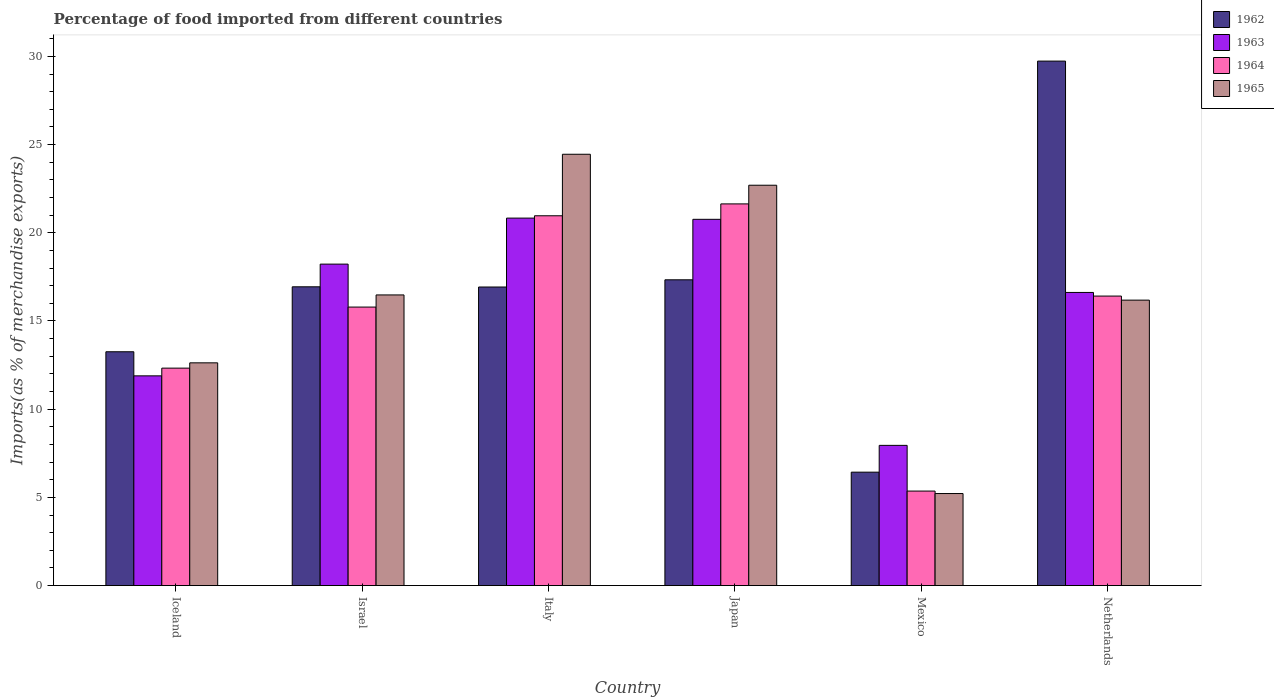How many groups of bars are there?
Provide a succinct answer. 6. Are the number of bars per tick equal to the number of legend labels?
Keep it short and to the point. Yes. Are the number of bars on each tick of the X-axis equal?
Provide a succinct answer. Yes. How many bars are there on the 4th tick from the left?
Make the answer very short. 4. How many bars are there on the 4th tick from the right?
Ensure brevity in your answer.  4. What is the percentage of imports to different countries in 1962 in Israel?
Make the answer very short. 16.94. Across all countries, what is the maximum percentage of imports to different countries in 1965?
Give a very brief answer. 24.45. Across all countries, what is the minimum percentage of imports to different countries in 1964?
Your response must be concise. 5.36. What is the total percentage of imports to different countries in 1962 in the graph?
Offer a very short reply. 100.62. What is the difference between the percentage of imports to different countries in 1964 in Italy and that in Netherlands?
Offer a terse response. 4.55. What is the difference between the percentage of imports to different countries in 1963 in Iceland and the percentage of imports to different countries in 1964 in Netherlands?
Make the answer very short. -4.52. What is the average percentage of imports to different countries in 1964 per country?
Your answer should be very brief. 15.42. What is the difference between the percentage of imports to different countries of/in 1962 and percentage of imports to different countries of/in 1963 in Israel?
Give a very brief answer. -1.29. In how many countries, is the percentage of imports to different countries in 1964 greater than 21 %?
Make the answer very short. 1. What is the ratio of the percentage of imports to different countries in 1963 in Israel to that in Mexico?
Provide a succinct answer. 2.29. Is the difference between the percentage of imports to different countries in 1962 in Iceland and Mexico greater than the difference between the percentage of imports to different countries in 1963 in Iceland and Mexico?
Keep it short and to the point. Yes. What is the difference between the highest and the second highest percentage of imports to different countries in 1962?
Your answer should be very brief. -0.4. What is the difference between the highest and the lowest percentage of imports to different countries in 1963?
Give a very brief answer. 12.88. In how many countries, is the percentage of imports to different countries in 1962 greater than the average percentage of imports to different countries in 1962 taken over all countries?
Offer a terse response. 4. Is it the case that in every country, the sum of the percentage of imports to different countries in 1963 and percentage of imports to different countries in 1962 is greater than the sum of percentage of imports to different countries in 1965 and percentage of imports to different countries in 1964?
Your answer should be compact. No. What does the 4th bar from the left in Netherlands represents?
Your response must be concise. 1965. How many bars are there?
Your answer should be compact. 24. Are all the bars in the graph horizontal?
Your response must be concise. No. Does the graph contain any zero values?
Your response must be concise. No. Where does the legend appear in the graph?
Your answer should be very brief. Top right. How are the legend labels stacked?
Ensure brevity in your answer.  Vertical. What is the title of the graph?
Keep it short and to the point. Percentage of food imported from different countries. What is the label or title of the Y-axis?
Provide a short and direct response. Imports(as % of merchandise exports). What is the Imports(as % of merchandise exports) of 1962 in Iceland?
Offer a terse response. 13.26. What is the Imports(as % of merchandise exports) in 1963 in Iceland?
Keep it short and to the point. 11.89. What is the Imports(as % of merchandise exports) in 1964 in Iceland?
Your answer should be compact. 12.33. What is the Imports(as % of merchandise exports) in 1965 in Iceland?
Your answer should be very brief. 12.63. What is the Imports(as % of merchandise exports) of 1962 in Israel?
Ensure brevity in your answer.  16.94. What is the Imports(as % of merchandise exports) of 1963 in Israel?
Your answer should be compact. 18.22. What is the Imports(as % of merchandise exports) of 1964 in Israel?
Offer a terse response. 15.79. What is the Imports(as % of merchandise exports) in 1965 in Israel?
Provide a short and direct response. 16.48. What is the Imports(as % of merchandise exports) of 1962 in Italy?
Give a very brief answer. 16.93. What is the Imports(as % of merchandise exports) in 1963 in Italy?
Give a very brief answer. 20.83. What is the Imports(as % of merchandise exports) in 1964 in Italy?
Provide a short and direct response. 20.97. What is the Imports(as % of merchandise exports) of 1965 in Italy?
Provide a short and direct response. 24.45. What is the Imports(as % of merchandise exports) in 1962 in Japan?
Ensure brevity in your answer.  17.34. What is the Imports(as % of merchandise exports) in 1963 in Japan?
Your answer should be compact. 20.76. What is the Imports(as % of merchandise exports) in 1964 in Japan?
Your answer should be very brief. 21.64. What is the Imports(as % of merchandise exports) in 1965 in Japan?
Keep it short and to the point. 22.7. What is the Imports(as % of merchandise exports) of 1962 in Mexico?
Provide a succinct answer. 6.43. What is the Imports(as % of merchandise exports) of 1963 in Mexico?
Give a very brief answer. 7.95. What is the Imports(as % of merchandise exports) in 1964 in Mexico?
Keep it short and to the point. 5.36. What is the Imports(as % of merchandise exports) of 1965 in Mexico?
Your response must be concise. 5.22. What is the Imports(as % of merchandise exports) in 1962 in Netherlands?
Provide a short and direct response. 29.73. What is the Imports(as % of merchandise exports) of 1963 in Netherlands?
Provide a short and direct response. 16.62. What is the Imports(as % of merchandise exports) of 1964 in Netherlands?
Provide a short and direct response. 16.41. What is the Imports(as % of merchandise exports) of 1965 in Netherlands?
Offer a terse response. 16.18. Across all countries, what is the maximum Imports(as % of merchandise exports) of 1962?
Your answer should be compact. 29.73. Across all countries, what is the maximum Imports(as % of merchandise exports) of 1963?
Offer a terse response. 20.83. Across all countries, what is the maximum Imports(as % of merchandise exports) of 1964?
Offer a very short reply. 21.64. Across all countries, what is the maximum Imports(as % of merchandise exports) of 1965?
Your response must be concise. 24.45. Across all countries, what is the minimum Imports(as % of merchandise exports) of 1962?
Your answer should be compact. 6.43. Across all countries, what is the minimum Imports(as % of merchandise exports) in 1963?
Provide a succinct answer. 7.95. Across all countries, what is the minimum Imports(as % of merchandise exports) in 1964?
Give a very brief answer. 5.36. Across all countries, what is the minimum Imports(as % of merchandise exports) in 1965?
Make the answer very short. 5.22. What is the total Imports(as % of merchandise exports) in 1962 in the graph?
Your response must be concise. 100.62. What is the total Imports(as % of merchandise exports) of 1963 in the graph?
Your answer should be compact. 96.28. What is the total Imports(as % of merchandise exports) in 1964 in the graph?
Your response must be concise. 92.49. What is the total Imports(as % of merchandise exports) of 1965 in the graph?
Provide a succinct answer. 97.65. What is the difference between the Imports(as % of merchandise exports) in 1962 in Iceland and that in Israel?
Provide a short and direct response. -3.68. What is the difference between the Imports(as % of merchandise exports) of 1963 in Iceland and that in Israel?
Keep it short and to the point. -6.33. What is the difference between the Imports(as % of merchandise exports) in 1964 in Iceland and that in Israel?
Ensure brevity in your answer.  -3.46. What is the difference between the Imports(as % of merchandise exports) of 1965 in Iceland and that in Israel?
Ensure brevity in your answer.  -3.85. What is the difference between the Imports(as % of merchandise exports) of 1962 in Iceland and that in Italy?
Provide a short and direct response. -3.67. What is the difference between the Imports(as % of merchandise exports) of 1963 in Iceland and that in Italy?
Offer a terse response. -8.94. What is the difference between the Imports(as % of merchandise exports) of 1964 in Iceland and that in Italy?
Make the answer very short. -8.64. What is the difference between the Imports(as % of merchandise exports) of 1965 in Iceland and that in Italy?
Keep it short and to the point. -11.82. What is the difference between the Imports(as % of merchandise exports) of 1962 in Iceland and that in Japan?
Ensure brevity in your answer.  -4.08. What is the difference between the Imports(as % of merchandise exports) of 1963 in Iceland and that in Japan?
Your answer should be compact. -8.87. What is the difference between the Imports(as % of merchandise exports) in 1964 in Iceland and that in Japan?
Offer a very short reply. -9.31. What is the difference between the Imports(as % of merchandise exports) of 1965 in Iceland and that in Japan?
Offer a very short reply. -10.07. What is the difference between the Imports(as % of merchandise exports) in 1962 in Iceland and that in Mexico?
Provide a short and direct response. 6.83. What is the difference between the Imports(as % of merchandise exports) of 1963 in Iceland and that in Mexico?
Offer a terse response. 3.94. What is the difference between the Imports(as % of merchandise exports) in 1964 in Iceland and that in Mexico?
Your response must be concise. 6.97. What is the difference between the Imports(as % of merchandise exports) of 1965 in Iceland and that in Mexico?
Offer a very short reply. 7.41. What is the difference between the Imports(as % of merchandise exports) in 1962 in Iceland and that in Netherlands?
Offer a very short reply. -16.48. What is the difference between the Imports(as % of merchandise exports) of 1963 in Iceland and that in Netherlands?
Give a very brief answer. -4.73. What is the difference between the Imports(as % of merchandise exports) in 1964 in Iceland and that in Netherlands?
Make the answer very short. -4.08. What is the difference between the Imports(as % of merchandise exports) in 1965 in Iceland and that in Netherlands?
Make the answer very short. -3.56. What is the difference between the Imports(as % of merchandise exports) in 1962 in Israel and that in Italy?
Make the answer very short. 0.01. What is the difference between the Imports(as % of merchandise exports) in 1963 in Israel and that in Italy?
Keep it short and to the point. -2.61. What is the difference between the Imports(as % of merchandise exports) in 1964 in Israel and that in Italy?
Give a very brief answer. -5.18. What is the difference between the Imports(as % of merchandise exports) in 1965 in Israel and that in Italy?
Provide a short and direct response. -7.97. What is the difference between the Imports(as % of merchandise exports) in 1962 in Israel and that in Japan?
Offer a terse response. -0.4. What is the difference between the Imports(as % of merchandise exports) of 1963 in Israel and that in Japan?
Offer a very short reply. -2.54. What is the difference between the Imports(as % of merchandise exports) in 1964 in Israel and that in Japan?
Offer a terse response. -5.85. What is the difference between the Imports(as % of merchandise exports) in 1965 in Israel and that in Japan?
Ensure brevity in your answer.  -6.22. What is the difference between the Imports(as % of merchandise exports) in 1962 in Israel and that in Mexico?
Provide a short and direct response. 10.51. What is the difference between the Imports(as % of merchandise exports) of 1963 in Israel and that in Mexico?
Make the answer very short. 10.28. What is the difference between the Imports(as % of merchandise exports) in 1964 in Israel and that in Mexico?
Your answer should be very brief. 10.43. What is the difference between the Imports(as % of merchandise exports) in 1965 in Israel and that in Mexico?
Your answer should be very brief. 11.26. What is the difference between the Imports(as % of merchandise exports) in 1962 in Israel and that in Netherlands?
Ensure brevity in your answer.  -12.8. What is the difference between the Imports(as % of merchandise exports) in 1963 in Israel and that in Netherlands?
Keep it short and to the point. 1.61. What is the difference between the Imports(as % of merchandise exports) in 1964 in Israel and that in Netherlands?
Give a very brief answer. -0.62. What is the difference between the Imports(as % of merchandise exports) of 1965 in Israel and that in Netherlands?
Offer a terse response. 0.3. What is the difference between the Imports(as % of merchandise exports) in 1962 in Italy and that in Japan?
Ensure brevity in your answer.  -0.41. What is the difference between the Imports(as % of merchandise exports) of 1963 in Italy and that in Japan?
Your response must be concise. 0.07. What is the difference between the Imports(as % of merchandise exports) in 1964 in Italy and that in Japan?
Your response must be concise. -0.67. What is the difference between the Imports(as % of merchandise exports) in 1965 in Italy and that in Japan?
Your answer should be compact. 1.76. What is the difference between the Imports(as % of merchandise exports) of 1962 in Italy and that in Mexico?
Make the answer very short. 10.5. What is the difference between the Imports(as % of merchandise exports) of 1963 in Italy and that in Mexico?
Keep it short and to the point. 12.88. What is the difference between the Imports(as % of merchandise exports) in 1964 in Italy and that in Mexico?
Ensure brevity in your answer.  15.61. What is the difference between the Imports(as % of merchandise exports) in 1965 in Italy and that in Mexico?
Your response must be concise. 19.24. What is the difference between the Imports(as % of merchandise exports) in 1962 in Italy and that in Netherlands?
Ensure brevity in your answer.  -12.81. What is the difference between the Imports(as % of merchandise exports) of 1963 in Italy and that in Netherlands?
Offer a terse response. 4.21. What is the difference between the Imports(as % of merchandise exports) in 1964 in Italy and that in Netherlands?
Keep it short and to the point. 4.55. What is the difference between the Imports(as % of merchandise exports) in 1965 in Italy and that in Netherlands?
Offer a terse response. 8.27. What is the difference between the Imports(as % of merchandise exports) of 1962 in Japan and that in Mexico?
Keep it short and to the point. 10.91. What is the difference between the Imports(as % of merchandise exports) in 1963 in Japan and that in Mexico?
Keep it short and to the point. 12.82. What is the difference between the Imports(as % of merchandise exports) in 1964 in Japan and that in Mexico?
Offer a terse response. 16.28. What is the difference between the Imports(as % of merchandise exports) in 1965 in Japan and that in Mexico?
Ensure brevity in your answer.  17.48. What is the difference between the Imports(as % of merchandise exports) in 1962 in Japan and that in Netherlands?
Provide a succinct answer. -12.4. What is the difference between the Imports(as % of merchandise exports) in 1963 in Japan and that in Netherlands?
Offer a terse response. 4.15. What is the difference between the Imports(as % of merchandise exports) of 1964 in Japan and that in Netherlands?
Give a very brief answer. 5.23. What is the difference between the Imports(as % of merchandise exports) in 1965 in Japan and that in Netherlands?
Ensure brevity in your answer.  6.51. What is the difference between the Imports(as % of merchandise exports) in 1962 in Mexico and that in Netherlands?
Ensure brevity in your answer.  -23.31. What is the difference between the Imports(as % of merchandise exports) in 1963 in Mexico and that in Netherlands?
Provide a short and direct response. -8.67. What is the difference between the Imports(as % of merchandise exports) in 1964 in Mexico and that in Netherlands?
Your answer should be compact. -11.05. What is the difference between the Imports(as % of merchandise exports) of 1965 in Mexico and that in Netherlands?
Your response must be concise. -10.97. What is the difference between the Imports(as % of merchandise exports) in 1962 in Iceland and the Imports(as % of merchandise exports) in 1963 in Israel?
Give a very brief answer. -4.97. What is the difference between the Imports(as % of merchandise exports) in 1962 in Iceland and the Imports(as % of merchandise exports) in 1964 in Israel?
Keep it short and to the point. -2.53. What is the difference between the Imports(as % of merchandise exports) of 1962 in Iceland and the Imports(as % of merchandise exports) of 1965 in Israel?
Keep it short and to the point. -3.22. What is the difference between the Imports(as % of merchandise exports) of 1963 in Iceland and the Imports(as % of merchandise exports) of 1964 in Israel?
Keep it short and to the point. -3.9. What is the difference between the Imports(as % of merchandise exports) in 1963 in Iceland and the Imports(as % of merchandise exports) in 1965 in Israel?
Ensure brevity in your answer.  -4.59. What is the difference between the Imports(as % of merchandise exports) in 1964 in Iceland and the Imports(as % of merchandise exports) in 1965 in Israel?
Ensure brevity in your answer.  -4.15. What is the difference between the Imports(as % of merchandise exports) of 1962 in Iceland and the Imports(as % of merchandise exports) of 1963 in Italy?
Make the answer very short. -7.58. What is the difference between the Imports(as % of merchandise exports) of 1962 in Iceland and the Imports(as % of merchandise exports) of 1964 in Italy?
Provide a short and direct response. -7.71. What is the difference between the Imports(as % of merchandise exports) in 1962 in Iceland and the Imports(as % of merchandise exports) in 1965 in Italy?
Your answer should be very brief. -11.2. What is the difference between the Imports(as % of merchandise exports) in 1963 in Iceland and the Imports(as % of merchandise exports) in 1964 in Italy?
Ensure brevity in your answer.  -9.08. What is the difference between the Imports(as % of merchandise exports) in 1963 in Iceland and the Imports(as % of merchandise exports) in 1965 in Italy?
Your response must be concise. -12.56. What is the difference between the Imports(as % of merchandise exports) of 1964 in Iceland and the Imports(as % of merchandise exports) of 1965 in Italy?
Ensure brevity in your answer.  -12.13. What is the difference between the Imports(as % of merchandise exports) of 1962 in Iceland and the Imports(as % of merchandise exports) of 1963 in Japan?
Provide a succinct answer. -7.51. What is the difference between the Imports(as % of merchandise exports) in 1962 in Iceland and the Imports(as % of merchandise exports) in 1964 in Japan?
Your response must be concise. -8.38. What is the difference between the Imports(as % of merchandise exports) of 1962 in Iceland and the Imports(as % of merchandise exports) of 1965 in Japan?
Your answer should be compact. -9.44. What is the difference between the Imports(as % of merchandise exports) of 1963 in Iceland and the Imports(as % of merchandise exports) of 1964 in Japan?
Keep it short and to the point. -9.75. What is the difference between the Imports(as % of merchandise exports) of 1963 in Iceland and the Imports(as % of merchandise exports) of 1965 in Japan?
Provide a succinct answer. -10.81. What is the difference between the Imports(as % of merchandise exports) in 1964 in Iceland and the Imports(as % of merchandise exports) in 1965 in Japan?
Your answer should be very brief. -10.37. What is the difference between the Imports(as % of merchandise exports) in 1962 in Iceland and the Imports(as % of merchandise exports) in 1963 in Mexico?
Keep it short and to the point. 5.31. What is the difference between the Imports(as % of merchandise exports) in 1962 in Iceland and the Imports(as % of merchandise exports) in 1964 in Mexico?
Offer a terse response. 7.9. What is the difference between the Imports(as % of merchandise exports) of 1962 in Iceland and the Imports(as % of merchandise exports) of 1965 in Mexico?
Give a very brief answer. 8.04. What is the difference between the Imports(as % of merchandise exports) of 1963 in Iceland and the Imports(as % of merchandise exports) of 1964 in Mexico?
Provide a succinct answer. 6.53. What is the difference between the Imports(as % of merchandise exports) of 1963 in Iceland and the Imports(as % of merchandise exports) of 1965 in Mexico?
Make the answer very short. 6.67. What is the difference between the Imports(as % of merchandise exports) in 1964 in Iceland and the Imports(as % of merchandise exports) in 1965 in Mexico?
Give a very brief answer. 7.11. What is the difference between the Imports(as % of merchandise exports) in 1962 in Iceland and the Imports(as % of merchandise exports) in 1963 in Netherlands?
Offer a very short reply. -3.36. What is the difference between the Imports(as % of merchandise exports) of 1962 in Iceland and the Imports(as % of merchandise exports) of 1964 in Netherlands?
Provide a short and direct response. -3.16. What is the difference between the Imports(as % of merchandise exports) in 1962 in Iceland and the Imports(as % of merchandise exports) in 1965 in Netherlands?
Offer a very short reply. -2.93. What is the difference between the Imports(as % of merchandise exports) in 1963 in Iceland and the Imports(as % of merchandise exports) in 1964 in Netherlands?
Make the answer very short. -4.52. What is the difference between the Imports(as % of merchandise exports) of 1963 in Iceland and the Imports(as % of merchandise exports) of 1965 in Netherlands?
Give a very brief answer. -4.29. What is the difference between the Imports(as % of merchandise exports) of 1964 in Iceland and the Imports(as % of merchandise exports) of 1965 in Netherlands?
Provide a succinct answer. -3.86. What is the difference between the Imports(as % of merchandise exports) in 1962 in Israel and the Imports(as % of merchandise exports) in 1963 in Italy?
Your answer should be compact. -3.89. What is the difference between the Imports(as % of merchandise exports) in 1962 in Israel and the Imports(as % of merchandise exports) in 1964 in Italy?
Give a very brief answer. -4.03. What is the difference between the Imports(as % of merchandise exports) in 1962 in Israel and the Imports(as % of merchandise exports) in 1965 in Italy?
Offer a very short reply. -7.51. What is the difference between the Imports(as % of merchandise exports) of 1963 in Israel and the Imports(as % of merchandise exports) of 1964 in Italy?
Provide a succinct answer. -2.74. What is the difference between the Imports(as % of merchandise exports) of 1963 in Israel and the Imports(as % of merchandise exports) of 1965 in Italy?
Provide a succinct answer. -6.23. What is the difference between the Imports(as % of merchandise exports) of 1964 in Israel and the Imports(as % of merchandise exports) of 1965 in Italy?
Provide a short and direct response. -8.66. What is the difference between the Imports(as % of merchandise exports) in 1962 in Israel and the Imports(as % of merchandise exports) in 1963 in Japan?
Keep it short and to the point. -3.83. What is the difference between the Imports(as % of merchandise exports) of 1962 in Israel and the Imports(as % of merchandise exports) of 1964 in Japan?
Offer a terse response. -4.7. What is the difference between the Imports(as % of merchandise exports) of 1962 in Israel and the Imports(as % of merchandise exports) of 1965 in Japan?
Your answer should be compact. -5.76. What is the difference between the Imports(as % of merchandise exports) in 1963 in Israel and the Imports(as % of merchandise exports) in 1964 in Japan?
Give a very brief answer. -3.41. What is the difference between the Imports(as % of merchandise exports) of 1963 in Israel and the Imports(as % of merchandise exports) of 1965 in Japan?
Your response must be concise. -4.47. What is the difference between the Imports(as % of merchandise exports) in 1964 in Israel and the Imports(as % of merchandise exports) in 1965 in Japan?
Provide a succinct answer. -6.91. What is the difference between the Imports(as % of merchandise exports) of 1962 in Israel and the Imports(as % of merchandise exports) of 1963 in Mexico?
Make the answer very short. 8.99. What is the difference between the Imports(as % of merchandise exports) in 1962 in Israel and the Imports(as % of merchandise exports) in 1964 in Mexico?
Your answer should be compact. 11.58. What is the difference between the Imports(as % of merchandise exports) of 1962 in Israel and the Imports(as % of merchandise exports) of 1965 in Mexico?
Provide a succinct answer. 11.72. What is the difference between the Imports(as % of merchandise exports) in 1963 in Israel and the Imports(as % of merchandise exports) in 1964 in Mexico?
Provide a short and direct response. 12.87. What is the difference between the Imports(as % of merchandise exports) in 1963 in Israel and the Imports(as % of merchandise exports) in 1965 in Mexico?
Your answer should be compact. 13.01. What is the difference between the Imports(as % of merchandise exports) in 1964 in Israel and the Imports(as % of merchandise exports) in 1965 in Mexico?
Your answer should be very brief. 10.57. What is the difference between the Imports(as % of merchandise exports) of 1962 in Israel and the Imports(as % of merchandise exports) of 1963 in Netherlands?
Make the answer very short. 0.32. What is the difference between the Imports(as % of merchandise exports) in 1962 in Israel and the Imports(as % of merchandise exports) in 1964 in Netherlands?
Provide a succinct answer. 0.53. What is the difference between the Imports(as % of merchandise exports) of 1962 in Israel and the Imports(as % of merchandise exports) of 1965 in Netherlands?
Your answer should be compact. 0.76. What is the difference between the Imports(as % of merchandise exports) in 1963 in Israel and the Imports(as % of merchandise exports) in 1964 in Netherlands?
Give a very brief answer. 1.81. What is the difference between the Imports(as % of merchandise exports) in 1963 in Israel and the Imports(as % of merchandise exports) in 1965 in Netherlands?
Offer a very short reply. 2.04. What is the difference between the Imports(as % of merchandise exports) of 1964 in Israel and the Imports(as % of merchandise exports) of 1965 in Netherlands?
Keep it short and to the point. -0.39. What is the difference between the Imports(as % of merchandise exports) in 1962 in Italy and the Imports(as % of merchandise exports) in 1963 in Japan?
Your response must be concise. -3.84. What is the difference between the Imports(as % of merchandise exports) of 1962 in Italy and the Imports(as % of merchandise exports) of 1964 in Japan?
Your response must be concise. -4.71. What is the difference between the Imports(as % of merchandise exports) of 1962 in Italy and the Imports(as % of merchandise exports) of 1965 in Japan?
Your answer should be very brief. -5.77. What is the difference between the Imports(as % of merchandise exports) in 1963 in Italy and the Imports(as % of merchandise exports) in 1964 in Japan?
Offer a terse response. -0.81. What is the difference between the Imports(as % of merchandise exports) in 1963 in Italy and the Imports(as % of merchandise exports) in 1965 in Japan?
Keep it short and to the point. -1.86. What is the difference between the Imports(as % of merchandise exports) in 1964 in Italy and the Imports(as % of merchandise exports) in 1965 in Japan?
Offer a terse response. -1.73. What is the difference between the Imports(as % of merchandise exports) of 1962 in Italy and the Imports(as % of merchandise exports) of 1963 in Mexico?
Your answer should be very brief. 8.98. What is the difference between the Imports(as % of merchandise exports) in 1962 in Italy and the Imports(as % of merchandise exports) in 1964 in Mexico?
Your answer should be very brief. 11.57. What is the difference between the Imports(as % of merchandise exports) in 1962 in Italy and the Imports(as % of merchandise exports) in 1965 in Mexico?
Provide a succinct answer. 11.71. What is the difference between the Imports(as % of merchandise exports) of 1963 in Italy and the Imports(as % of merchandise exports) of 1964 in Mexico?
Ensure brevity in your answer.  15.48. What is the difference between the Imports(as % of merchandise exports) of 1963 in Italy and the Imports(as % of merchandise exports) of 1965 in Mexico?
Provide a succinct answer. 15.62. What is the difference between the Imports(as % of merchandise exports) of 1964 in Italy and the Imports(as % of merchandise exports) of 1965 in Mexico?
Keep it short and to the point. 15.75. What is the difference between the Imports(as % of merchandise exports) in 1962 in Italy and the Imports(as % of merchandise exports) in 1963 in Netherlands?
Your answer should be compact. 0.31. What is the difference between the Imports(as % of merchandise exports) of 1962 in Italy and the Imports(as % of merchandise exports) of 1964 in Netherlands?
Keep it short and to the point. 0.51. What is the difference between the Imports(as % of merchandise exports) of 1962 in Italy and the Imports(as % of merchandise exports) of 1965 in Netherlands?
Make the answer very short. 0.74. What is the difference between the Imports(as % of merchandise exports) of 1963 in Italy and the Imports(as % of merchandise exports) of 1964 in Netherlands?
Your answer should be very brief. 4.42. What is the difference between the Imports(as % of merchandise exports) in 1963 in Italy and the Imports(as % of merchandise exports) in 1965 in Netherlands?
Ensure brevity in your answer.  4.65. What is the difference between the Imports(as % of merchandise exports) of 1964 in Italy and the Imports(as % of merchandise exports) of 1965 in Netherlands?
Give a very brief answer. 4.78. What is the difference between the Imports(as % of merchandise exports) in 1962 in Japan and the Imports(as % of merchandise exports) in 1963 in Mexico?
Keep it short and to the point. 9.39. What is the difference between the Imports(as % of merchandise exports) of 1962 in Japan and the Imports(as % of merchandise exports) of 1964 in Mexico?
Provide a succinct answer. 11.98. What is the difference between the Imports(as % of merchandise exports) of 1962 in Japan and the Imports(as % of merchandise exports) of 1965 in Mexico?
Offer a terse response. 12.12. What is the difference between the Imports(as % of merchandise exports) of 1963 in Japan and the Imports(as % of merchandise exports) of 1964 in Mexico?
Your answer should be very brief. 15.41. What is the difference between the Imports(as % of merchandise exports) of 1963 in Japan and the Imports(as % of merchandise exports) of 1965 in Mexico?
Give a very brief answer. 15.55. What is the difference between the Imports(as % of merchandise exports) of 1964 in Japan and the Imports(as % of merchandise exports) of 1965 in Mexico?
Provide a succinct answer. 16.42. What is the difference between the Imports(as % of merchandise exports) in 1962 in Japan and the Imports(as % of merchandise exports) in 1963 in Netherlands?
Your answer should be very brief. 0.72. What is the difference between the Imports(as % of merchandise exports) of 1962 in Japan and the Imports(as % of merchandise exports) of 1964 in Netherlands?
Your answer should be compact. 0.92. What is the difference between the Imports(as % of merchandise exports) of 1962 in Japan and the Imports(as % of merchandise exports) of 1965 in Netherlands?
Offer a terse response. 1.15. What is the difference between the Imports(as % of merchandise exports) in 1963 in Japan and the Imports(as % of merchandise exports) in 1964 in Netherlands?
Your answer should be compact. 4.35. What is the difference between the Imports(as % of merchandise exports) of 1963 in Japan and the Imports(as % of merchandise exports) of 1965 in Netherlands?
Offer a very short reply. 4.58. What is the difference between the Imports(as % of merchandise exports) of 1964 in Japan and the Imports(as % of merchandise exports) of 1965 in Netherlands?
Give a very brief answer. 5.46. What is the difference between the Imports(as % of merchandise exports) of 1962 in Mexico and the Imports(as % of merchandise exports) of 1963 in Netherlands?
Offer a terse response. -10.19. What is the difference between the Imports(as % of merchandise exports) in 1962 in Mexico and the Imports(as % of merchandise exports) in 1964 in Netherlands?
Your answer should be very brief. -9.98. What is the difference between the Imports(as % of merchandise exports) of 1962 in Mexico and the Imports(as % of merchandise exports) of 1965 in Netherlands?
Make the answer very short. -9.75. What is the difference between the Imports(as % of merchandise exports) in 1963 in Mexico and the Imports(as % of merchandise exports) in 1964 in Netherlands?
Your answer should be very brief. -8.46. What is the difference between the Imports(as % of merchandise exports) of 1963 in Mexico and the Imports(as % of merchandise exports) of 1965 in Netherlands?
Give a very brief answer. -8.23. What is the difference between the Imports(as % of merchandise exports) of 1964 in Mexico and the Imports(as % of merchandise exports) of 1965 in Netherlands?
Provide a short and direct response. -10.83. What is the average Imports(as % of merchandise exports) of 1962 per country?
Your answer should be very brief. 16.77. What is the average Imports(as % of merchandise exports) in 1963 per country?
Provide a succinct answer. 16.05. What is the average Imports(as % of merchandise exports) of 1964 per country?
Your answer should be compact. 15.41. What is the average Imports(as % of merchandise exports) of 1965 per country?
Your answer should be compact. 16.28. What is the difference between the Imports(as % of merchandise exports) in 1962 and Imports(as % of merchandise exports) in 1963 in Iceland?
Offer a terse response. 1.37. What is the difference between the Imports(as % of merchandise exports) in 1962 and Imports(as % of merchandise exports) in 1964 in Iceland?
Keep it short and to the point. 0.93. What is the difference between the Imports(as % of merchandise exports) in 1962 and Imports(as % of merchandise exports) in 1965 in Iceland?
Offer a terse response. 0.63. What is the difference between the Imports(as % of merchandise exports) in 1963 and Imports(as % of merchandise exports) in 1964 in Iceland?
Make the answer very short. -0.44. What is the difference between the Imports(as % of merchandise exports) of 1963 and Imports(as % of merchandise exports) of 1965 in Iceland?
Provide a short and direct response. -0.74. What is the difference between the Imports(as % of merchandise exports) in 1964 and Imports(as % of merchandise exports) in 1965 in Iceland?
Offer a terse response. -0.3. What is the difference between the Imports(as % of merchandise exports) of 1962 and Imports(as % of merchandise exports) of 1963 in Israel?
Your answer should be compact. -1.29. What is the difference between the Imports(as % of merchandise exports) in 1962 and Imports(as % of merchandise exports) in 1964 in Israel?
Your answer should be very brief. 1.15. What is the difference between the Imports(as % of merchandise exports) of 1962 and Imports(as % of merchandise exports) of 1965 in Israel?
Your answer should be compact. 0.46. What is the difference between the Imports(as % of merchandise exports) of 1963 and Imports(as % of merchandise exports) of 1964 in Israel?
Offer a very short reply. 2.43. What is the difference between the Imports(as % of merchandise exports) of 1963 and Imports(as % of merchandise exports) of 1965 in Israel?
Your response must be concise. 1.75. What is the difference between the Imports(as % of merchandise exports) of 1964 and Imports(as % of merchandise exports) of 1965 in Israel?
Your response must be concise. -0.69. What is the difference between the Imports(as % of merchandise exports) of 1962 and Imports(as % of merchandise exports) of 1963 in Italy?
Your answer should be very brief. -3.91. What is the difference between the Imports(as % of merchandise exports) of 1962 and Imports(as % of merchandise exports) of 1964 in Italy?
Give a very brief answer. -4.04. What is the difference between the Imports(as % of merchandise exports) of 1962 and Imports(as % of merchandise exports) of 1965 in Italy?
Provide a succinct answer. -7.53. What is the difference between the Imports(as % of merchandise exports) in 1963 and Imports(as % of merchandise exports) in 1964 in Italy?
Ensure brevity in your answer.  -0.13. What is the difference between the Imports(as % of merchandise exports) of 1963 and Imports(as % of merchandise exports) of 1965 in Italy?
Your response must be concise. -3.62. What is the difference between the Imports(as % of merchandise exports) of 1964 and Imports(as % of merchandise exports) of 1965 in Italy?
Provide a succinct answer. -3.49. What is the difference between the Imports(as % of merchandise exports) of 1962 and Imports(as % of merchandise exports) of 1963 in Japan?
Provide a succinct answer. -3.43. What is the difference between the Imports(as % of merchandise exports) in 1962 and Imports(as % of merchandise exports) in 1964 in Japan?
Your answer should be very brief. -4.3. What is the difference between the Imports(as % of merchandise exports) of 1962 and Imports(as % of merchandise exports) of 1965 in Japan?
Give a very brief answer. -5.36. What is the difference between the Imports(as % of merchandise exports) in 1963 and Imports(as % of merchandise exports) in 1964 in Japan?
Give a very brief answer. -0.87. What is the difference between the Imports(as % of merchandise exports) in 1963 and Imports(as % of merchandise exports) in 1965 in Japan?
Your answer should be very brief. -1.93. What is the difference between the Imports(as % of merchandise exports) in 1964 and Imports(as % of merchandise exports) in 1965 in Japan?
Your response must be concise. -1.06. What is the difference between the Imports(as % of merchandise exports) of 1962 and Imports(as % of merchandise exports) of 1963 in Mexico?
Keep it short and to the point. -1.52. What is the difference between the Imports(as % of merchandise exports) of 1962 and Imports(as % of merchandise exports) of 1964 in Mexico?
Give a very brief answer. 1.07. What is the difference between the Imports(as % of merchandise exports) of 1962 and Imports(as % of merchandise exports) of 1965 in Mexico?
Offer a very short reply. 1.21. What is the difference between the Imports(as % of merchandise exports) in 1963 and Imports(as % of merchandise exports) in 1964 in Mexico?
Provide a short and direct response. 2.59. What is the difference between the Imports(as % of merchandise exports) in 1963 and Imports(as % of merchandise exports) in 1965 in Mexico?
Your response must be concise. 2.73. What is the difference between the Imports(as % of merchandise exports) of 1964 and Imports(as % of merchandise exports) of 1965 in Mexico?
Your answer should be very brief. 0.14. What is the difference between the Imports(as % of merchandise exports) of 1962 and Imports(as % of merchandise exports) of 1963 in Netherlands?
Your response must be concise. 13.12. What is the difference between the Imports(as % of merchandise exports) of 1962 and Imports(as % of merchandise exports) of 1964 in Netherlands?
Offer a terse response. 13.32. What is the difference between the Imports(as % of merchandise exports) of 1962 and Imports(as % of merchandise exports) of 1965 in Netherlands?
Your response must be concise. 13.55. What is the difference between the Imports(as % of merchandise exports) of 1963 and Imports(as % of merchandise exports) of 1964 in Netherlands?
Keep it short and to the point. 0.21. What is the difference between the Imports(as % of merchandise exports) of 1963 and Imports(as % of merchandise exports) of 1965 in Netherlands?
Your response must be concise. 0.44. What is the difference between the Imports(as % of merchandise exports) in 1964 and Imports(as % of merchandise exports) in 1965 in Netherlands?
Provide a succinct answer. 0.23. What is the ratio of the Imports(as % of merchandise exports) of 1962 in Iceland to that in Israel?
Offer a terse response. 0.78. What is the ratio of the Imports(as % of merchandise exports) of 1963 in Iceland to that in Israel?
Ensure brevity in your answer.  0.65. What is the ratio of the Imports(as % of merchandise exports) in 1964 in Iceland to that in Israel?
Your answer should be compact. 0.78. What is the ratio of the Imports(as % of merchandise exports) of 1965 in Iceland to that in Israel?
Make the answer very short. 0.77. What is the ratio of the Imports(as % of merchandise exports) in 1962 in Iceland to that in Italy?
Offer a very short reply. 0.78. What is the ratio of the Imports(as % of merchandise exports) in 1963 in Iceland to that in Italy?
Make the answer very short. 0.57. What is the ratio of the Imports(as % of merchandise exports) of 1964 in Iceland to that in Italy?
Provide a succinct answer. 0.59. What is the ratio of the Imports(as % of merchandise exports) of 1965 in Iceland to that in Italy?
Give a very brief answer. 0.52. What is the ratio of the Imports(as % of merchandise exports) of 1962 in Iceland to that in Japan?
Your response must be concise. 0.76. What is the ratio of the Imports(as % of merchandise exports) of 1963 in Iceland to that in Japan?
Your response must be concise. 0.57. What is the ratio of the Imports(as % of merchandise exports) in 1964 in Iceland to that in Japan?
Your answer should be compact. 0.57. What is the ratio of the Imports(as % of merchandise exports) in 1965 in Iceland to that in Japan?
Your response must be concise. 0.56. What is the ratio of the Imports(as % of merchandise exports) of 1962 in Iceland to that in Mexico?
Your answer should be very brief. 2.06. What is the ratio of the Imports(as % of merchandise exports) of 1963 in Iceland to that in Mexico?
Your answer should be very brief. 1.5. What is the ratio of the Imports(as % of merchandise exports) in 1964 in Iceland to that in Mexico?
Offer a very short reply. 2.3. What is the ratio of the Imports(as % of merchandise exports) of 1965 in Iceland to that in Mexico?
Ensure brevity in your answer.  2.42. What is the ratio of the Imports(as % of merchandise exports) of 1962 in Iceland to that in Netherlands?
Your response must be concise. 0.45. What is the ratio of the Imports(as % of merchandise exports) in 1963 in Iceland to that in Netherlands?
Provide a succinct answer. 0.72. What is the ratio of the Imports(as % of merchandise exports) of 1964 in Iceland to that in Netherlands?
Give a very brief answer. 0.75. What is the ratio of the Imports(as % of merchandise exports) of 1965 in Iceland to that in Netherlands?
Your response must be concise. 0.78. What is the ratio of the Imports(as % of merchandise exports) of 1962 in Israel to that in Italy?
Provide a short and direct response. 1. What is the ratio of the Imports(as % of merchandise exports) of 1963 in Israel to that in Italy?
Offer a terse response. 0.87. What is the ratio of the Imports(as % of merchandise exports) in 1964 in Israel to that in Italy?
Make the answer very short. 0.75. What is the ratio of the Imports(as % of merchandise exports) in 1965 in Israel to that in Italy?
Provide a short and direct response. 0.67. What is the ratio of the Imports(as % of merchandise exports) in 1962 in Israel to that in Japan?
Provide a short and direct response. 0.98. What is the ratio of the Imports(as % of merchandise exports) of 1963 in Israel to that in Japan?
Offer a terse response. 0.88. What is the ratio of the Imports(as % of merchandise exports) in 1964 in Israel to that in Japan?
Provide a succinct answer. 0.73. What is the ratio of the Imports(as % of merchandise exports) of 1965 in Israel to that in Japan?
Offer a very short reply. 0.73. What is the ratio of the Imports(as % of merchandise exports) in 1962 in Israel to that in Mexico?
Your response must be concise. 2.63. What is the ratio of the Imports(as % of merchandise exports) in 1963 in Israel to that in Mexico?
Your answer should be very brief. 2.29. What is the ratio of the Imports(as % of merchandise exports) of 1964 in Israel to that in Mexico?
Make the answer very short. 2.95. What is the ratio of the Imports(as % of merchandise exports) in 1965 in Israel to that in Mexico?
Keep it short and to the point. 3.16. What is the ratio of the Imports(as % of merchandise exports) of 1962 in Israel to that in Netherlands?
Ensure brevity in your answer.  0.57. What is the ratio of the Imports(as % of merchandise exports) in 1963 in Israel to that in Netherlands?
Give a very brief answer. 1.1. What is the ratio of the Imports(as % of merchandise exports) of 1965 in Israel to that in Netherlands?
Your answer should be very brief. 1.02. What is the ratio of the Imports(as % of merchandise exports) in 1962 in Italy to that in Japan?
Give a very brief answer. 0.98. What is the ratio of the Imports(as % of merchandise exports) of 1963 in Italy to that in Japan?
Offer a terse response. 1. What is the ratio of the Imports(as % of merchandise exports) of 1964 in Italy to that in Japan?
Offer a very short reply. 0.97. What is the ratio of the Imports(as % of merchandise exports) in 1965 in Italy to that in Japan?
Give a very brief answer. 1.08. What is the ratio of the Imports(as % of merchandise exports) in 1962 in Italy to that in Mexico?
Provide a succinct answer. 2.63. What is the ratio of the Imports(as % of merchandise exports) in 1963 in Italy to that in Mexico?
Your response must be concise. 2.62. What is the ratio of the Imports(as % of merchandise exports) of 1964 in Italy to that in Mexico?
Your answer should be very brief. 3.91. What is the ratio of the Imports(as % of merchandise exports) of 1965 in Italy to that in Mexico?
Offer a very short reply. 4.69. What is the ratio of the Imports(as % of merchandise exports) of 1962 in Italy to that in Netherlands?
Make the answer very short. 0.57. What is the ratio of the Imports(as % of merchandise exports) of 1963 in Italy to that in Netherlands?
Your answer should be very brief. 1.25. What is the ratio of the Imports(as % of merchandise exports) of 1964 in Italy to that in Netherlands?
Offer a terse response. 1.28. What is the ratio of the Imports(as % of merchandise exports) of 1965 in Italy to that in Netherlands?
Make the answer very short. 1.51. What is the ratio of the Imports(as % of merchandise exports) in 1962 in Japan to that in Mexico?
Your response must be concise. 2.7. What is the ratio of the Imports(as % of merchandise exports) in 1963 in Japan to that in Mexico?
Your response must be concise. 2.61. What is the ratio of the Imports(as % of merchandise exports) of 1964 in Japan to that in Mexico?
Keep it short and to the point. 4.04. What is the ratio of the Imports(as % of merchandise exports) of 1965 in Japan to that in Mexico?
Make the answer very short. 4.35. What is the ratio of the Imports(as % of merchandise exports) of 1962 in Japan to that in Netherlands?
Offer a very short reply. 0.58. What is the ratio of the Imports(as % of merchandise exports) of 1963 in Japan to that in Netherlands?
Offer a very short reply. 1.25. What is the ratio of the Imports(as % of merchandise exports) of 1964 in Japan to that in Netherlands?
Your response must be concise. 1.32. What is the ratio of the Imports(as % of merchandise exports) of 1965 in Japan to that in Netherlands?
Your answer should be compact. 1.4. What is the ratio of the Imports(as % of merchandise exports) of 1962 in Mexico to that in Netherlands?
Your answer should be very brief. 0.22. What is the ratio of the Imports(as % of merchandise exports) in 1963 in Mexico to that in Netherlands?
Keep it short and to the point. 0.48. What is the ratio of the Imports(as % of merchandise exports) in 1964 in Mexico to that in Netherlands?
Provide a short and direct response. 0.33. What is the ratio of the Imports(as % of merchandise exports) in 1965 in Mexico to that in Netherlands?
Provide a succinct answer. 0.32. What is the difference between the highest and the second highest Imports(as % of merchandise exports) of 1962?
Your response must be concise. 12.4. What is the difference between the highest and the second highest Imports(as % of merchandise exports) in 1963?
Give a very brief answer. 0.07. What is the difference between the highest and the second highest Imports(as % of merchandise exports) of 1964?
Give a very brief answer. 0.67. What is the difference between the highest and the second highest Imports(as % of merchandise exports) of 1965?
Your answer should be compact. 1.76. What is the difference between the highest and the lowest Imports(as % of merchandise exports) in 1962?
Your answer should be very brief. 23.31. What is the difference between the highest and the lowest Imports(as % of merchandise exports) in 1963?
Ensure brevity in your answer.  12.88. What is the difference between the highest and the lowest Imports(as % of merchandise exports) of 1964?
Give a very brief answer. 16.28. What is the difference between the highest and the lowest Imports(as % of merchandise exports) of 1965?
Give a very brief answer. 19.24. 